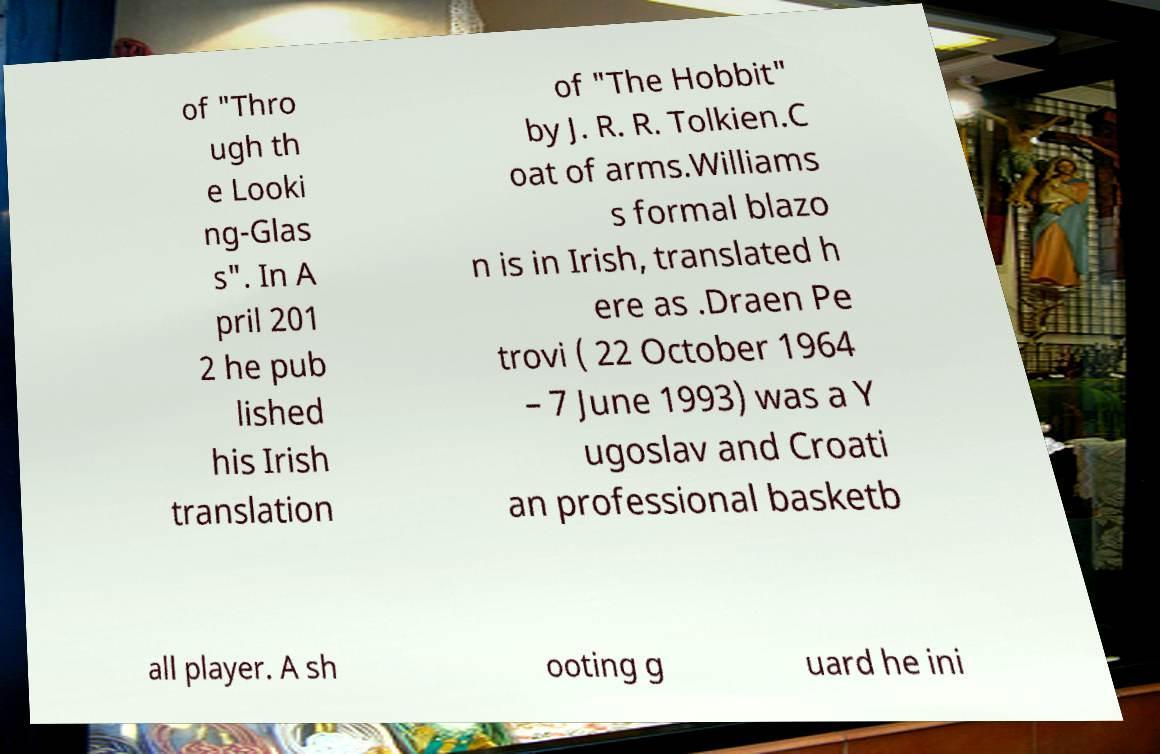There's text embedded in this image that I need extracted. Can you transcribe it verbatim? of "Thro ugh th e Looki ng-Glas s". In A pril 201 2 he pub lished his Irish translation of "The Hobbit" by J. R. R. Tolkien.C oat of arms.Williams s formal blazo n is in Irish, translated h ere as .Draen Pe trovi ( 22 October 1964 – 7 June 1993) was a Y ugoslav and Croati an professional basketb all player. A sh ooting g uard he ini 